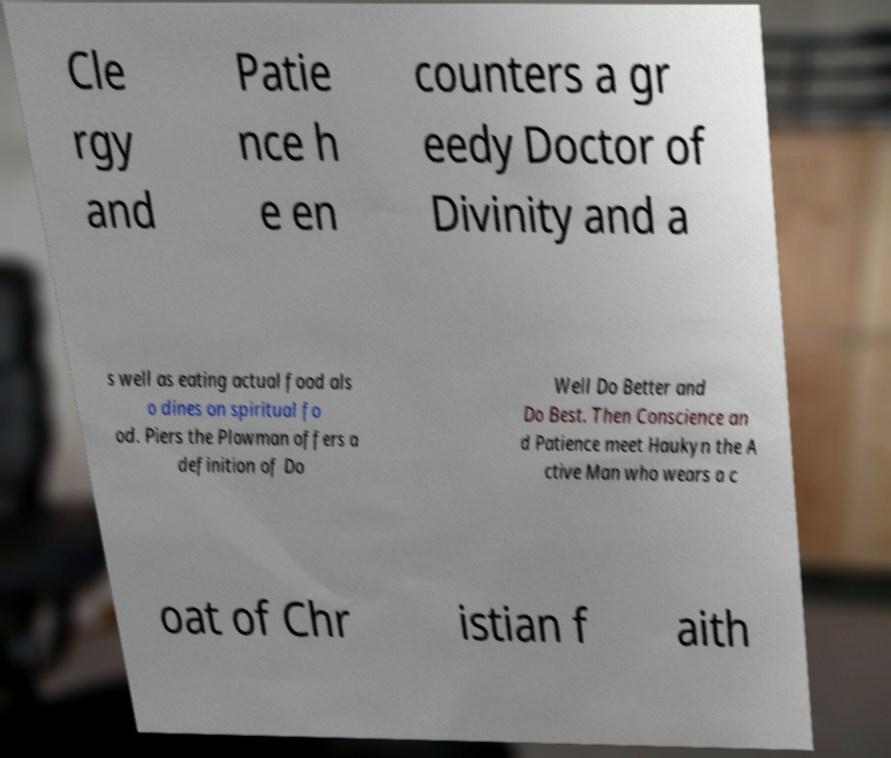Please identify and transcribe the text found in this image. Cle rgy and Patie nce h e en counters a gr eedy Doctor of Divinity and a s well as eating actual food als o dines on spiritual fo od. Piers the Plowman offers a definition of Do Well Do Better and Do Best. Then Conscience an d Patience meet Haukyn the A ctive Man who wears a c oat of Chr istian f aith 